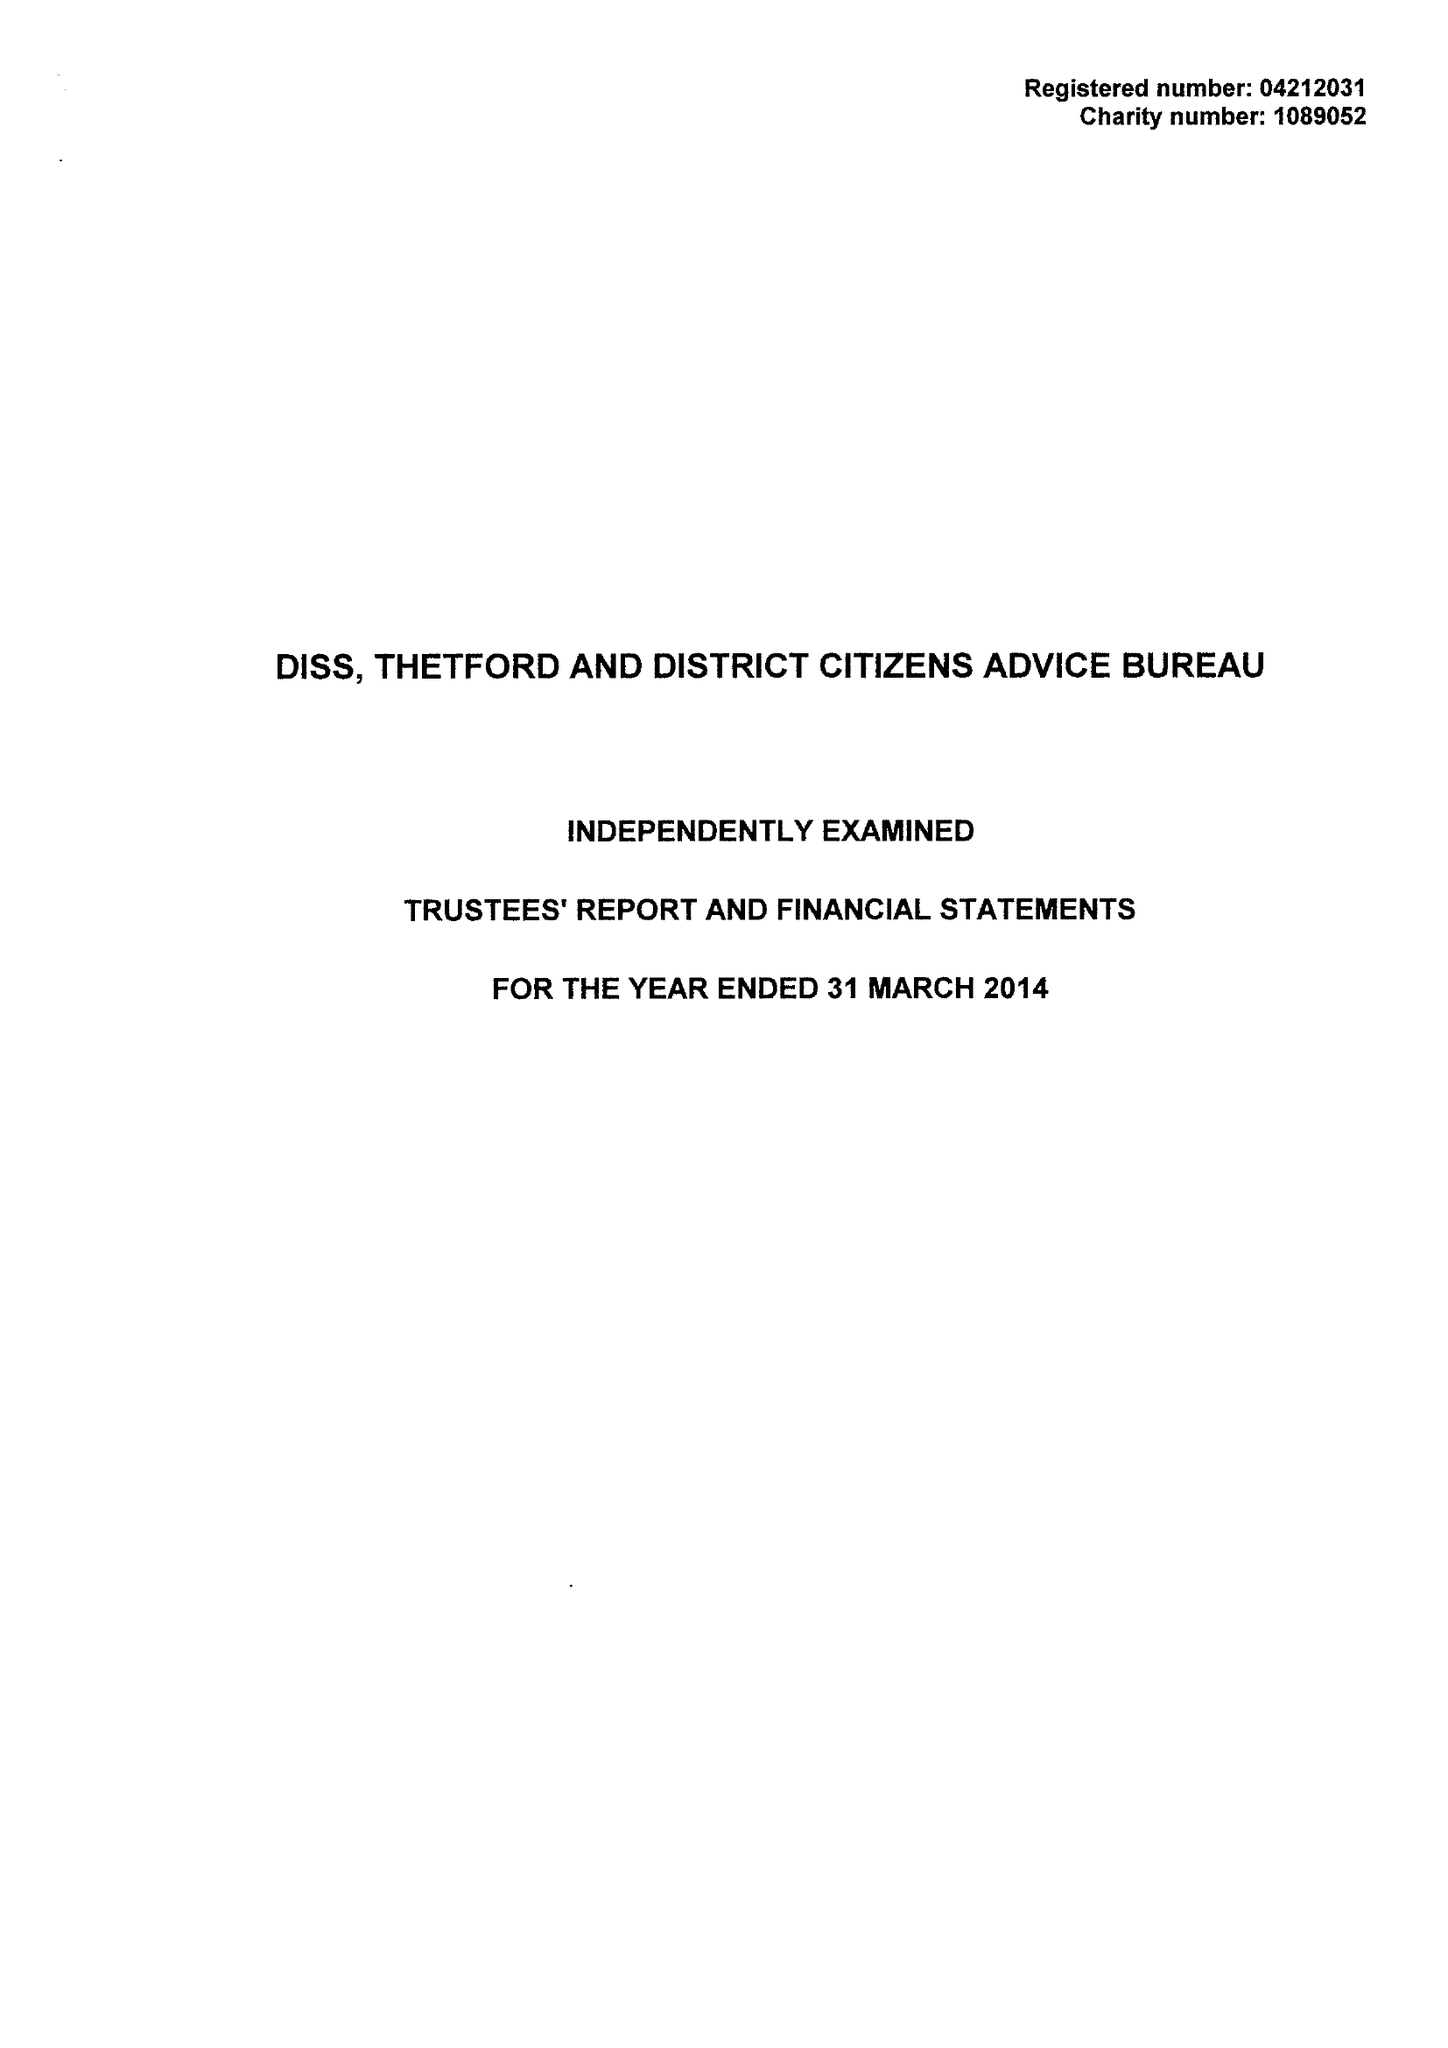What is the value for the charity_name?
Answer the question using a single word or phrase. Diss, Thetford and District Citizens Advice Bureau 